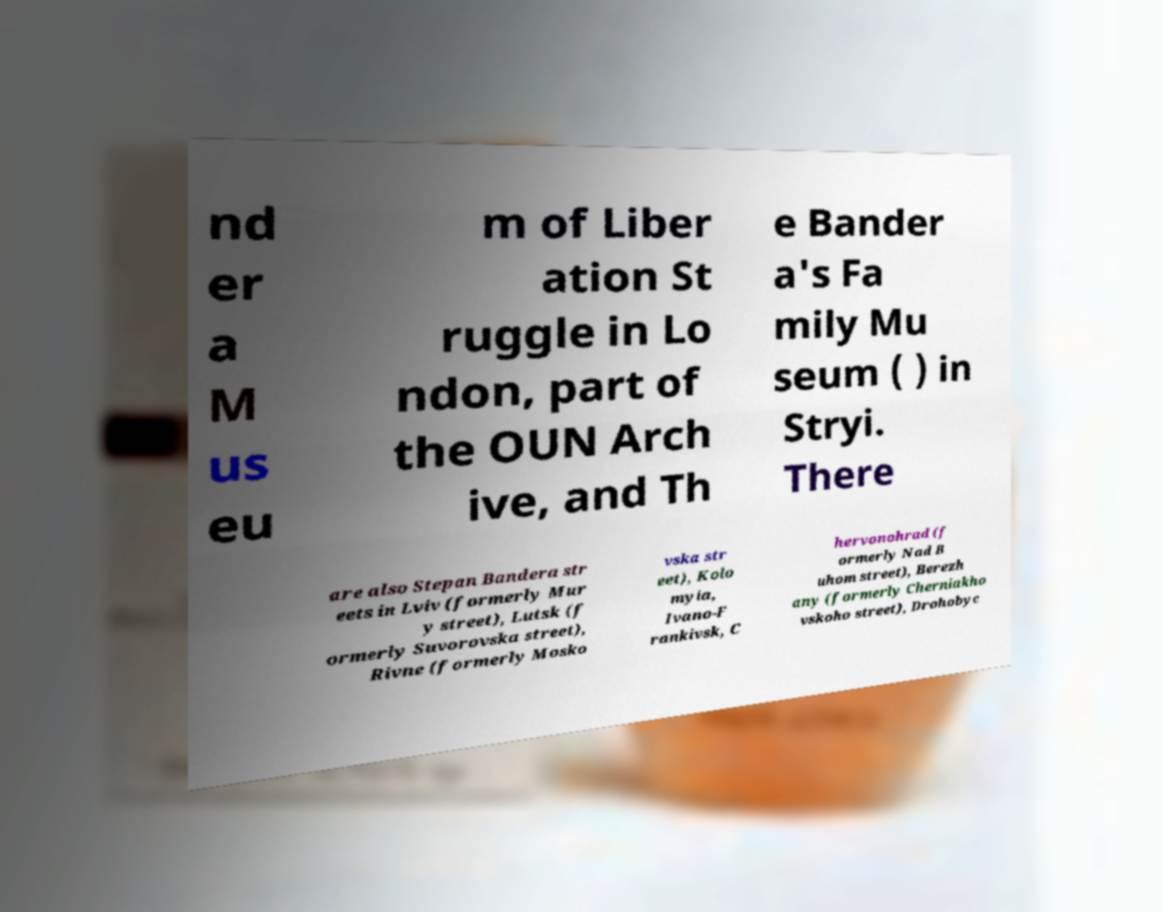I need the written content from this picture converted into text. Can you do that? nd er a M us eu m of Liber ation St ruggle in Lo ndon, part of the OUN Arch ive, and Th e Bander a's Fa mily Mu seum ( ) in Stryi. There are also Stepan Bandera str eets in Lviv (formerly Mur y street), Lutsk (f ormerly Suvorovska street), Rivne (formerly Mosko vska str eet), Kolo myia, Ivano-F rankivsk, C hervonohrad (f ormerly Nad B uhom street), Berezh any (formerly Cherniakho vskoho street), Drohobyc 